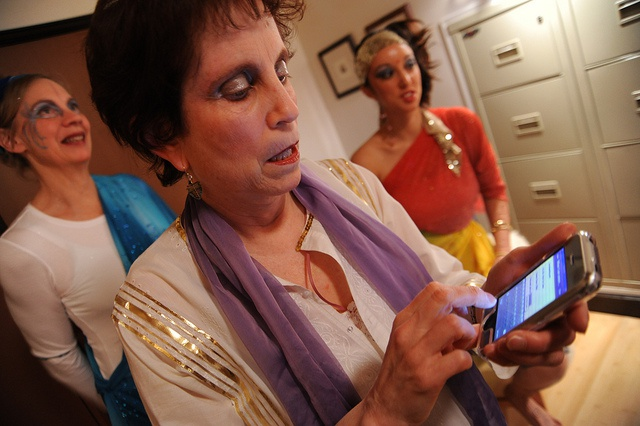Describe the objects in this image and their specific colors. I can see people in gray, maroon, black, and brown tones, people in gray, brown, black, and maroon tones, people in gray, brown, maroon, and salmon tones, and cell phone in gray, maroon, black, lightblue, and blue tones in this image. 